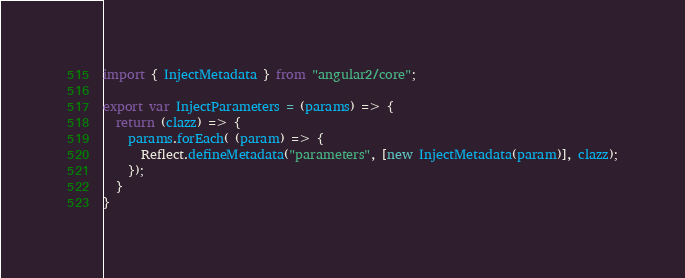<code> <loc_0><loc_0><loc_500><loc_500><_JavaScript_>import { InjectMetadata } from "angular2/core";

export var InjectParameters = (params) => {
  return (clazz) => {
    params.forEach( (param) => {
      Reflect.defineMetadata("parameters", [new InjectMetadata(param)], clazz);
    });
  }
}
</code> 